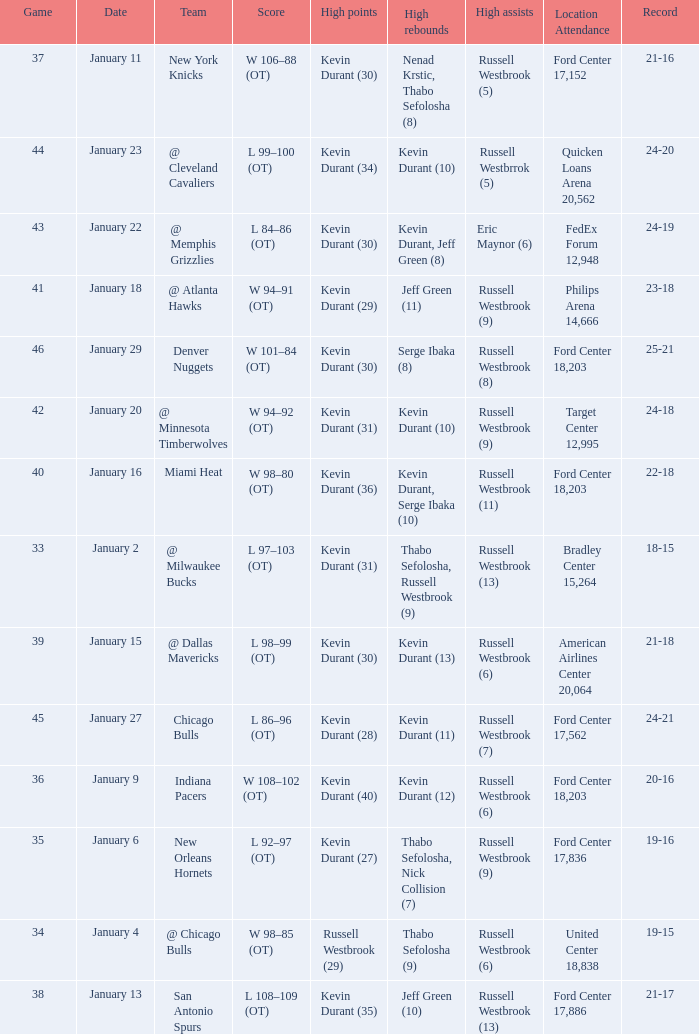Name the team for january 4 @ Chicago Bulls. 